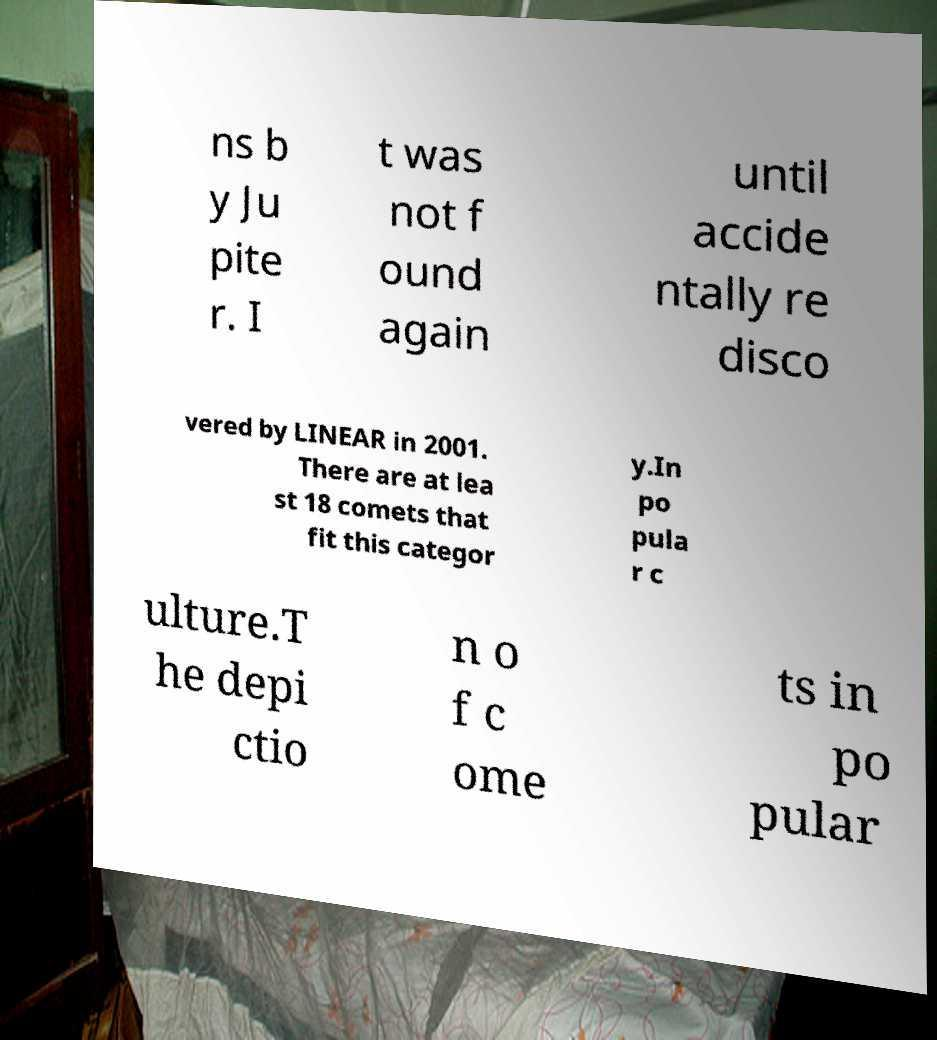Please read and relay the text visible in this image. What does it say? ns b y Ju pite r. I t was not f ound again until accide ntally re disco vered by LINEAR in 2001. There are at lea st 18 comets that fit this categor y.In po pula r c ulture.T he depi ctio n o f c ome ts in po pular 